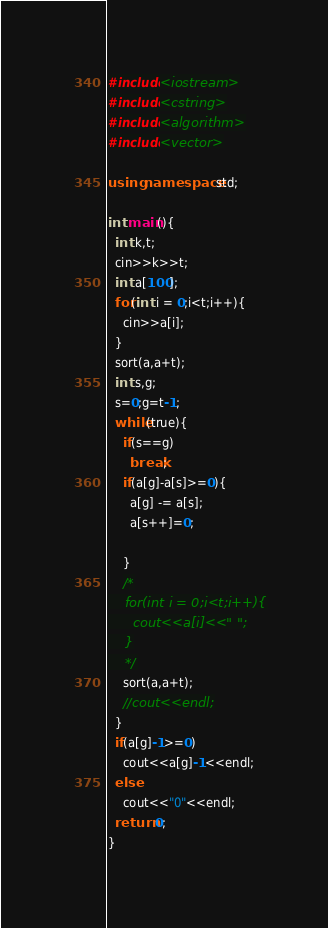<code> <loc_0><loc_0><loc_500><loc_500><_C++_>#include<iostream>
#include<cstring>
#include<algorithm>
#include<vector>

using namespace std;

int main(){
  int k,t;
  cin>>k>>t;
  int a[100];
  for(int i = 0;i<t;i++){
    cin>>a[i];
  }
  sort(a,a+t);
  int s,g;
  s=0;g=t-1;
  while(true){
    if(s==g)
      break;
    if(a[g]-a[s]>=0){
      a[g] -= a[s];
      a[s++]=0;

    }
    /*
    for(int i = 0;i<t;i++){
      cout<<a[i]<<" ";
    }
    */
    sort(a,a+t);
    //cout<<endl;
  }
  if(a[g]-1>=0)
    cout<<a[g]-1<<endl;
  else
    cout<<"0"<<endl;
  return 0;
}
</code> 